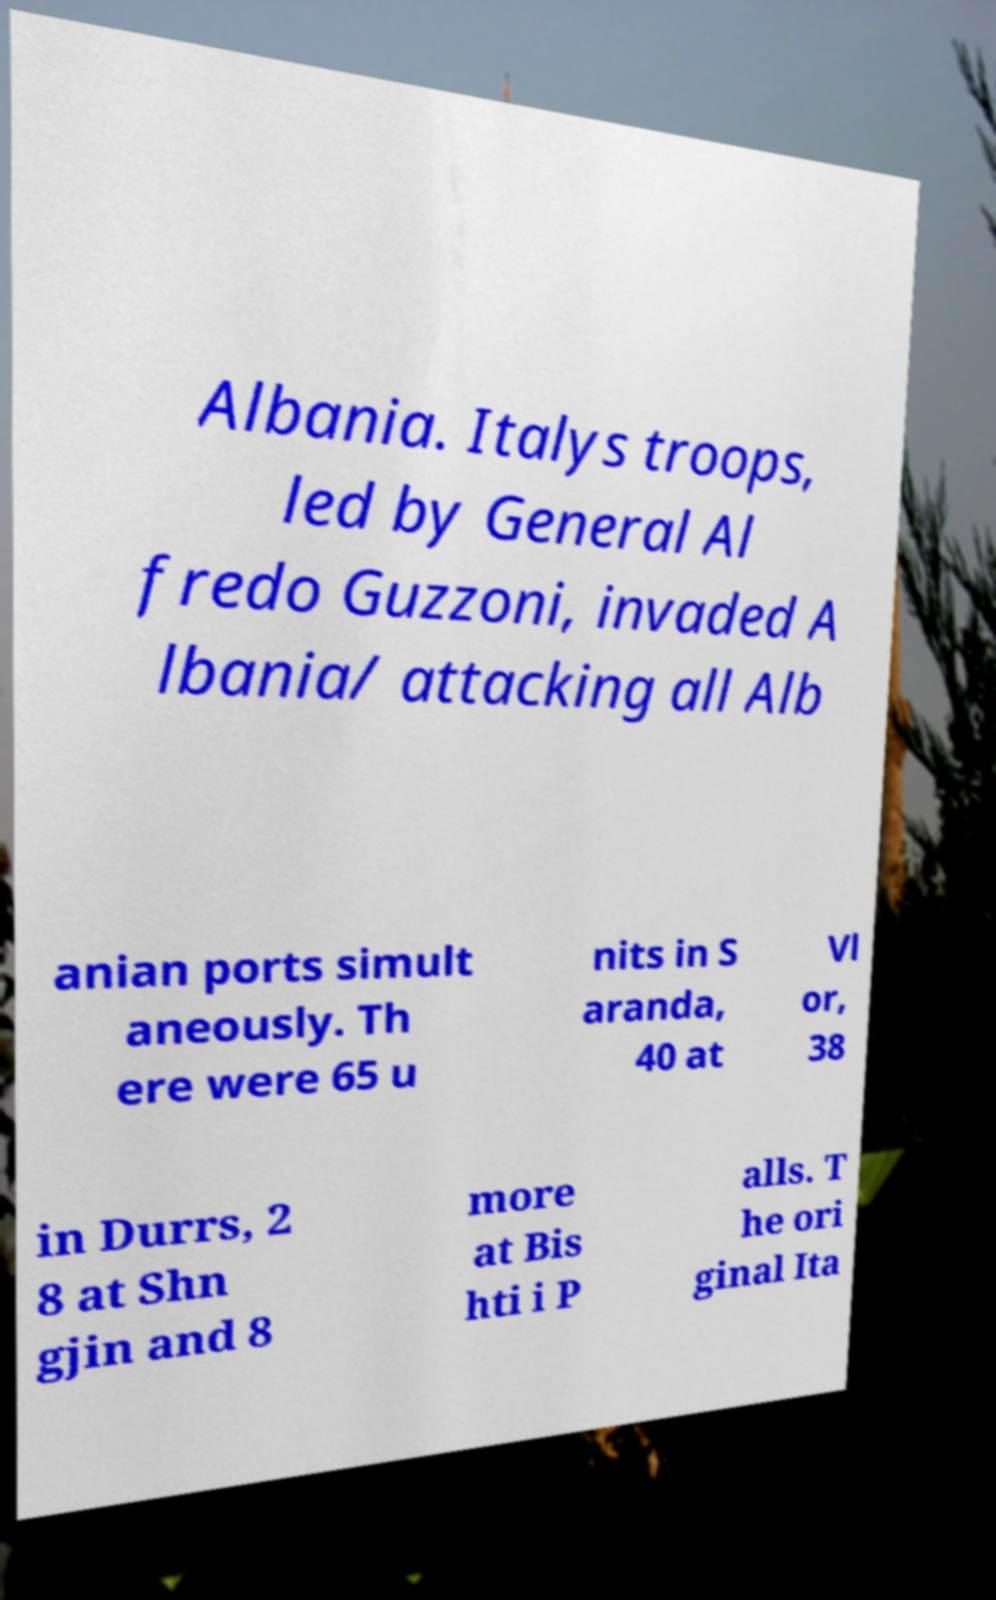What messages or text are displayed in this image? I need them in a readable, typed format. Albania. Italys troops, led by General Al fredo Guzzoni, invaded A lbania/ attacking all Alb anian ports simult aneously. Th ere were 65 u nits in S aranda, 40 at Vl or, 38 in Durrs, 2 8 at Shn gjin and 8 more at Bis hti i P alls. T he ori ginal Ita 